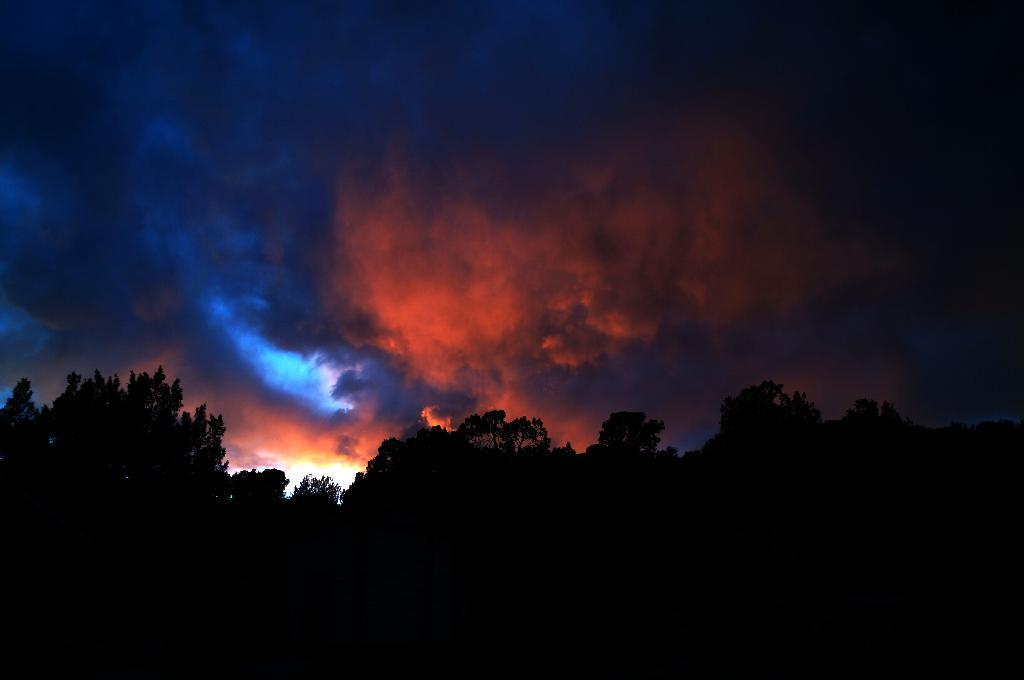What type of vegetation is present in the image? There is a group of trees in the image. What else can be seen in the image besides the trees? The sky is visible in the image. How would you describe the sky in the image? The sky appears to be cloudy. How many sisters are sitting on the curtain in the image? There are no sisters or curtains present in the image. 